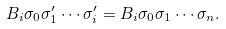<formula> <loc_0><loc_0><loc_500><loc_500>B _ { i } \sigma _ { 0 } \sigma ^ { \prime } _ { 1 } \cdots \sigma ^ { \prime } _ { i } = B _ { i } \sigma _ { 0 } \sigma _ { 1 } \cdots \sigma _ { n } .</formula> 